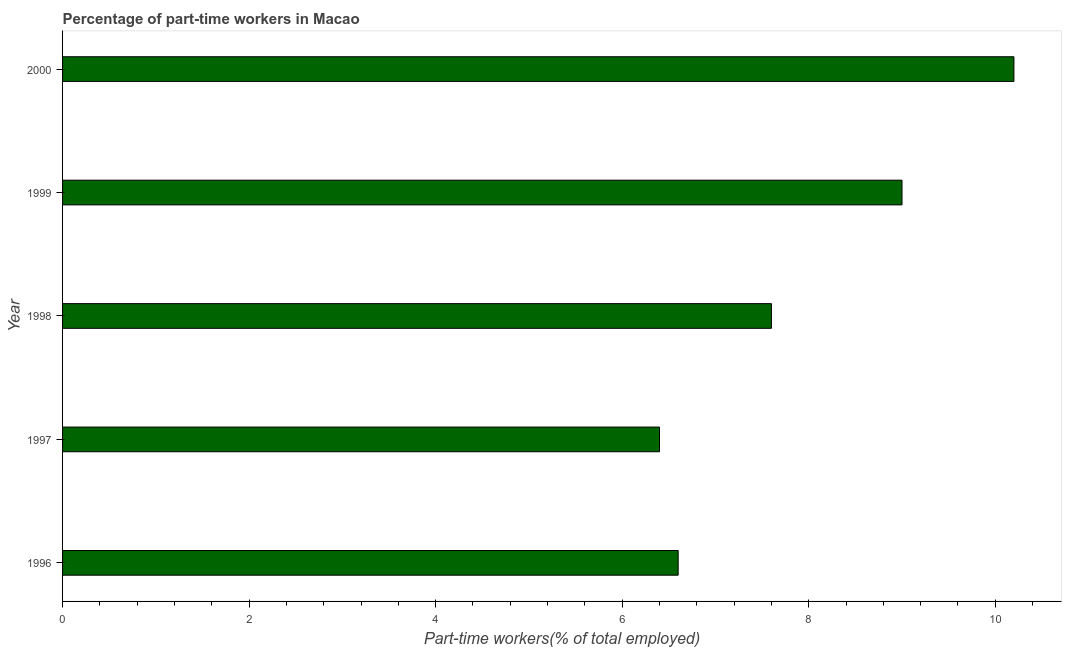Does the graph contain grids?
Make the answer very short. No. What is the title of the graph?
Keep it short and to the point. Percentage of part-time workers in Macao. What is the label or title of the X-axis?
Make the answer very short. Part-time workers(% of total employed). What is the label or title of the Y-axis?
Keep it short and to the point. Year. Across all years, what is the maximum percentage of part-time workers?
Provide a succinct answer. 10.2. Across all years, what is the minimum percentage of part-time workers?
Ensure brevity in your answer.  6.4. In which year was the percentage of part-time workers minimum?
Make the answer very short. 1997. What is the sum of the percentage of part-time workers?
Make the answer very short. 39.8. What is the average percentage of part-time workers per year?
Your response must be concise. 7.96. What is the median percentage of part-time workers?
Provide a succinct answer. 7.6. Do a majority of the years between 2000 and 1996 (inclusive) have percentage of part-time workers greater than 8.8 %?
Offer a terse response. Yes. What is the ratio of the percentage of part-time workers in 1996 to that in 1998?
Your response must be concise. 0.87. Is the percentage of part-time workers in 1999 less than that in 2000?
Your response must be concise. Yes. Is the difference between the percentage of part-time workers in 1999 and 2000 greater than the difference between any two years?
Offer a very short reply. No. What is the difference between the highest and the second highest percentage of part-time workers?
Give a very brief answer. 1.2. Is the sum of the percentage of part-time workers in 1997 and 1998 greater than the maximum percentage of part-time workers across all years?
Provide a short and direct response. Yes. What is the difference between the highest and the lowest percentage of part-time workers?
Ensure brevity in your answer.  3.8. In how many years, is the percentage of part-time workers greater than the average percentage of part-time workers taken over all years?
Provide a short and direct response. 2. How many bars are there?
Your response must be concise. 5. Are all the bars in the graph horizontal?
Make the answer very short. Yes. What is the difference between two consecutive major ticks on the X-axis?
Provide a short and direct response. 2. Are the values on the major ticks of X-axis written in scientific E-notation?
Ensure brevity in your answer.  No. What is the Part-time workers(% of total employed) of 1996?
Offer a terse response. 6.6. What is the Part-time workers(% of total employed) in 1997?
Keep it short and to the point. 6.4. What is the Part-time workers(% of total employed) in 1998?
Provide a short and direct response. 7.6. What is the Part-time workers(% of total employed) of 1999?
Give a very brief answer. 9. What is the Part-time workers(% of total employed) of 2000?
Your answer should be very brief. 10.2. What is the difference between the Part-time workers(% of total employed) in 1996 and 1997?
Provide a succinct answer. 0.2. What is the difference between the Part-time workers(% of total employed) in 1996 and 1998?
Provide a succinct answer. -1. What is the difference between the Part-time workers(% of total employed) in 1997 and 1998?
Make the answer very short. -1.2. What is the difference between the Part-time workers(% of total employed) in 1997 and 2000?
Offer a terse response. -3.8. What is the difference between the Part-time workers(% of total employed) in 1998 and 2000?
Provide a short and direct response. -2.6. What is the difference between the Part-time workers(% of total employed) in 1999 and 2000?
Provide a short and direct response. -1.2. What is the ratio of the Part-time workers(% of total employed) in 1996 to that in 1997?
Your response must be concise. 1.03. What is the ratio of the Part-time workers(% of total employed) in 1996 to that in 1998?
Give a very brief answer. 0.87. What is the ratio of the Part-time workers(% of total employed) in 1996 to that in 1999?
Give a very brief answer. 0.73. What is the ratio of the Part-time workers(% of total employed) in 1996 to that in 2000?
Keep it short and to the point. 0.65. What is the ratio of the Part-time workers(% of total employed) in 1997 to that in 1998?
Your response must be concise. 0.84. What is the ratio of the Part-time workers(% of total employed) in 1997 to that in 1999?
Offer a very short reply. 0.71. What is the ratio of the Part-time workers(% of total employed) in 1997 to that in 2000?
Your answer should be very brief. 0.63. What is the ratio of the Part-time workers(% of total employed) in 1998 to that in 1999?
Your response must be concise. 0.84. What is the ratio of the Part-time workers(% of total employed) in 1998 to that in 2000?
Provide a short and direct response. 0.74. What is the ratio of the Part-time workers(% of total employed) in 1999 to that in 2000?
Ensure brevity in your answer.  0.88. 